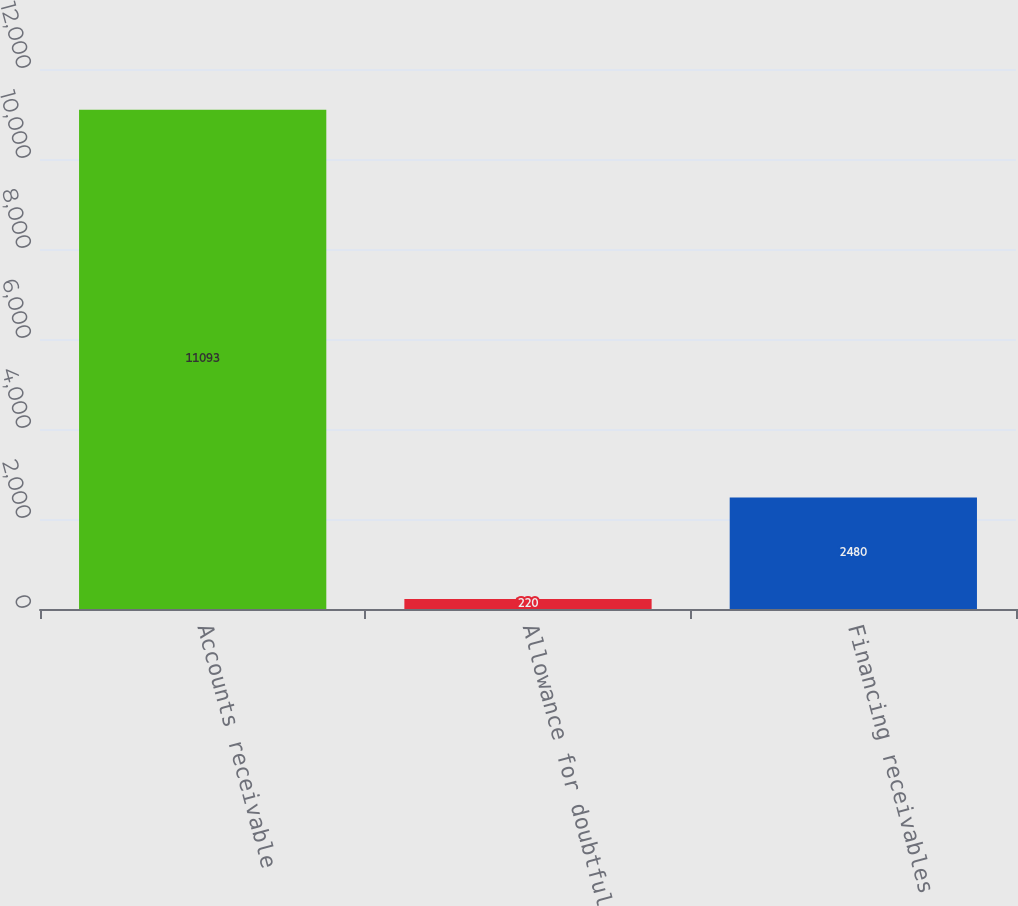Convert chart. <chart><loc_0><loc_0><loc_500><loc_500><bar_chart><fcel>Accounts receivable<fcel>Allowance for doubtful<fcel>Financing receivables<nl><fcel>11093<fcel>220<fcel>2480<nl></chart> 